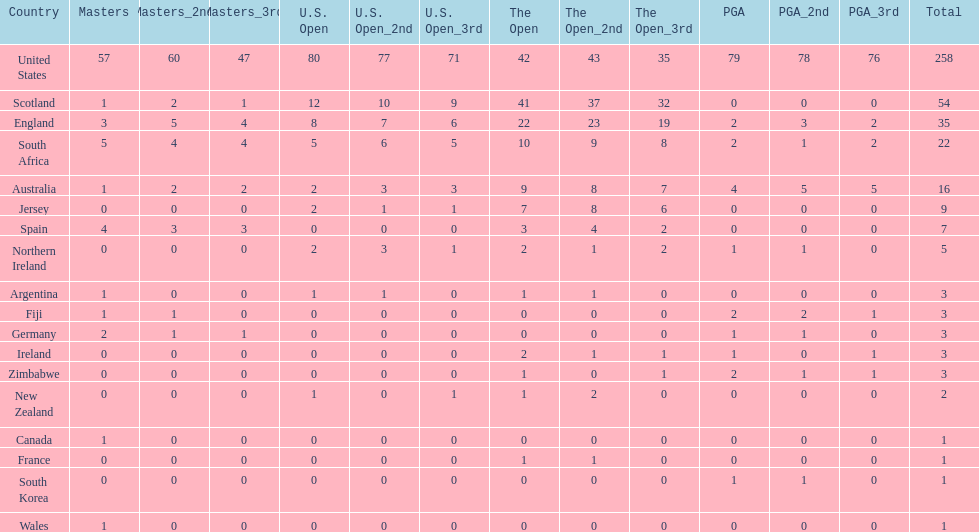Help me parse the entirety of this table. {'header': ['Country', 'Masters', 'Masters_2nd', 'Masters_3rd', 'U.S. Open', 'U.S. Open_2nd', 'U.S. Open_3rd', 'The Open', 'The Open_2nd', 'The Open_3rd', 'PGA', 'PGA_2nd', 'PGA_3rd', 'Total'], 'rows': [['United States', '57', '60', '47', '80', '77', '71', '42', '43', '35', '79', '78', '76', '258'], ['Scotland', '1', '2', '1', '12', '10', '9', '41', '37', '32', '0', '0', '0', '54'], ['England', '3', '5', '4', '8', '7', '6', '22', '23', '19', '2', '3', '2', '35'], ['South Africa', '5', '4', '4', '5', '6', '5', '10', '9', '8', '2', '1', '2', '22'], ['Australia', '1', '2', '2', '2', '3', '3', '9', '8', '7', '4', '5', '5', '16'], ['Jersey', '0', '0', '0', '2', '1', '1', '7', '8', '6', '0', '0', '0', '9'], ['Spain', '4', '3', '3', '0', '0', '0', '3', '4', '2', '0', '0', '0', '7'], ['Northern Ireland', '0', '0', '0', '2', '3', '1', '2', '1', '2', '1', '1', '0', '5'], ['Argentina', '1', '0', '0', '1', '1', '0', '1', '1', '0', '0', '0', '0', '3'], ['Fiji', '1', '1', '0', '0', '0', '0', '0', '0', '0', '2', '2', '1', '3'], ['Germany', '2', '1', '1', '0', '0', '0', '0', '0', '0', '1', '1', '0', '3'], ['Ireland', '0', '0', '0', '0', '0', '0', '2', '1', '1', '1', '0', '1', '3'], ['Zimbabwe', '0', '0', '0', '0', '0', '0', '1', '0', '1', '2', '1', '1', '3'], ['New Zealand', '0', '0', '0', '1', '0', '1', '1', '2', '0', '0', '0', '0', '2'], ['Canada', '1', '0', '0', '0', '0', '0', '0', '0', '0', '0', '0', '0', '1'], ['France', '0', '0', '0', '0', '0', '0', '1', '1', '0', '0', '0', '0', '1'], ['South Korea', '0', '0', '0', '0', '0', '0', '0', '0', '0', '1', '1', '0', '1'], ['Wales', '1', '0', '0', '0', '0', '0', '0', '0', '0', '0', '0', '0', '1']]} Which african country has the least champion golfers according to this table? Zimbabwe. 